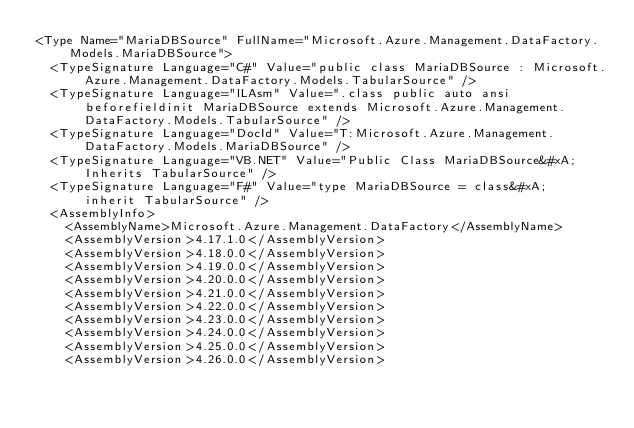Convert code to text. <code><loc_0><loc_0><loc_500><loc_500><_XML_><Type Name="MariaDBSource" FullName="Microsoft.Azure.Management.DataFactory.Models.MariaDBSource">
  <TypeSignature Language="C#" Value="public class MariaDBSource : Microsoft.Azure.Management.DataFactory.Models.TabularSource" />
  <TypeSignature Language="ILAsm" Value=".class public auto ansi beforefieldinit MariaDBSource extends Microsoft.Azure.Management.DataFactory.Models.TabularSource" />
  <TypeSignature Language="DocId" Value="T:Microsoft.Azure.Management.DataFactory.Models.MariaDBSource" />
  <TypeSignature Language="VB.NET" Value="Public Class MariaDBSource&#xA;Inherits TabularSource" />
  <TypeSignature Language="F#" Value="type MariaDBSource = class&#xA;    inherit TabularSource" />
  <AssemblyInfo>
    <AssemblyName>Microsoft.Azure.Management.DataFactory</AssemblyName>
    <AssemblyVersion>4.17.1.0</AssemblyVersion>
    <AssemblyVersion>4.18.0.0</AssemblyVersion>
    <AssemblyVersion>4.19.0.0</AssemblyVersion>
    <AssemblyVersion>4.20.0.0</AssemblyVersion>
    <AssemblyVersion>4.21.0.0</AssemblyVersion>
    <AssemblyVersion>4.22.0.0</AssemblyVersion>
    <AssemblyVersion>4.23.0.0</AssemblyVersion>
    <AssemblyVersion>4.24.0.0</AssemblyVersion>
    <AssemblyVersion>4.25.0.0</AssemblyVersion>
    <AssemblyVersion>4.26.0.0</AssemblyVersion></code> 